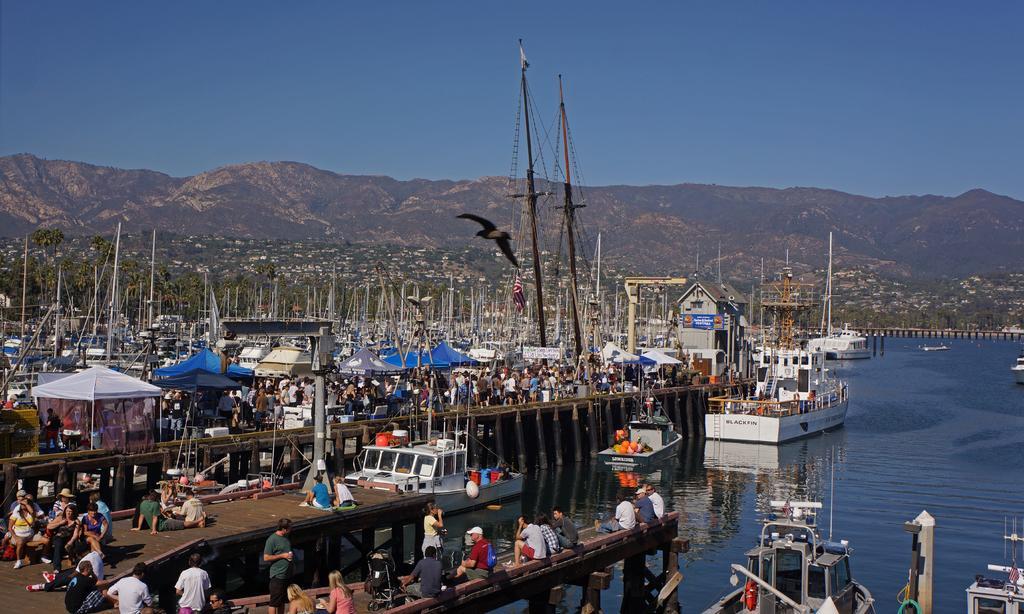How would you summarize this image in a sentence or two? In this image in the center there are ships on the water and there are persons on the bridge. There are tents, there are poles and in the background there are mountains. In the front on the top there is a bird flying in the sky. 